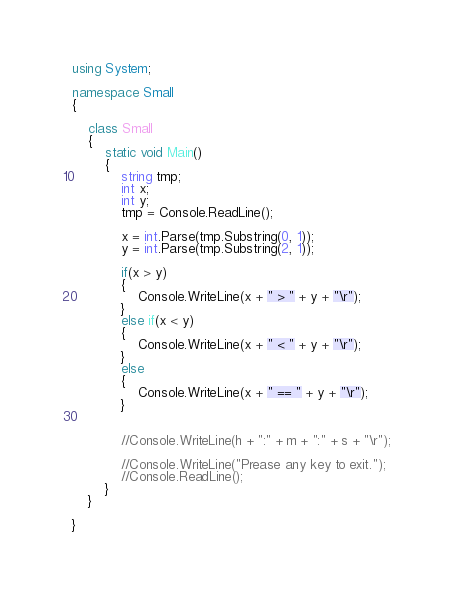Convert code to text. <code><loc_0><loc_0><loc_500><loc_500><_C#_>using System;

namespace Small
{

	class Small
	{
		static void Main()
		{
            string tmp;
            int x;
            int y;
            tmp = Console.ReadLine();

            x = int.Parse(tmp.Substring(0, 1));
            y = int.Parse(tmp.Substring(2, 1));
            
            if(x > y)
			{
				Console.WriteLine(x + " > " + y + "\r");
			}
			else if(x < y)
			{
				Console.WriteLine(x + " < " + y + "\r");
			}
			else
			{
				Console.WriteLine(x + " == " + y + "\r");
			}
			
			
			//Console.WriteLine(h + ":" + m + ":" + s + "\r");
			
			//Console.WriteLine("Prease any key to exit.");
            //Console.ReadLine();
		}
	}

}</code> 